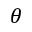<formula> <loc_0><loc_0><loc_500><loc_500>\theta</formula> 